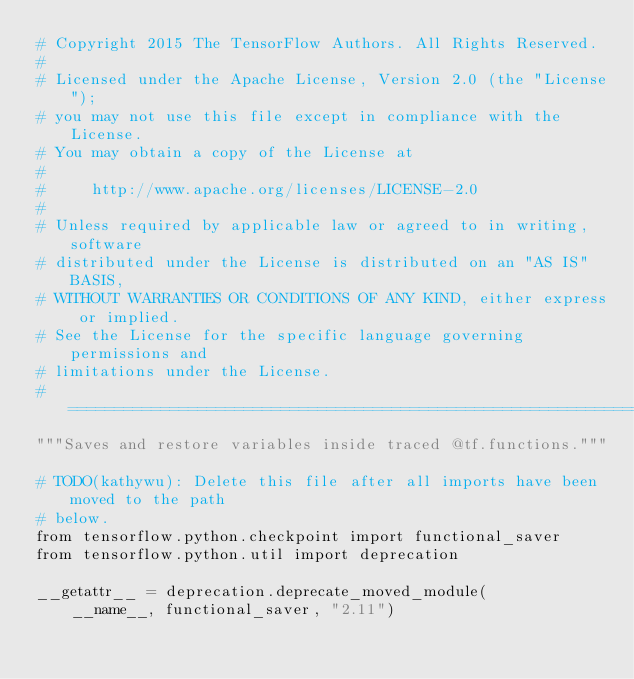Convert code to text. <code><loc_0><loc_0><loc_500><loc_500><_Python_># Copyright 2015 The TensorFlow Authors. All Rights Reserved.
#
# Licensed under the Apache License, Version 2.0 (the "License");
# you may not use this file except in compliance with the License.
# You may obtain a copy of the License at
#
#     http://www.apache.org/licenses/LICENSE-2.0
#
# Unless required by applicable law or agreed to in writing, software
# distributed under the License is distributed on an "AS IS" BASIS,
# WITHOUT WARRANTIES OR CONDITIONS OF ANY KIND, either express or implied.
# See the License for the specific language governing permissions and
# limitations under the License.
# ==============================================================================
"""Saves and restore variables inside traced @tf.functions."""

# TODO(kathywu): Delete this file after all imports have been moved to the path
# below.
from tensorflow.python.checkpoint import functional_saver
from tensorflow.python.util import deprecation

__getattr__ = deprecation.deprecate_moved_module(
    __name__, functional_saver, "2.11")
</code> 